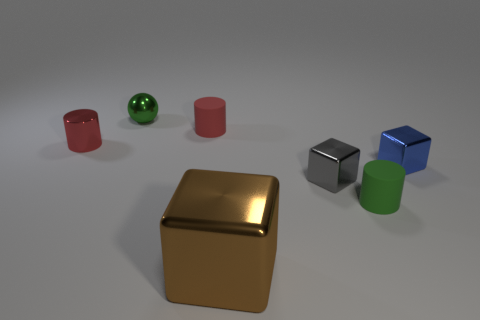How would you describe the lighting and shadows in this scene? The scene is evenly lit with a soft light source from above, casting gentle shadows directly underneath the objects. This illumination creates a calming ambiance and accentuates the shapes of the objects by producing muted shadows that give a sense of the dimensionality of the objects without being overly harsh. Does the lighting affect the colors of the objects in any way? Yes, the soft lighting minimally alters the colors of the objects, maintaining their vibrancy and allowing their true hues to be displayed. However, the reflective surfaces on some of the objects, such as the gold cube and green sphere, catch and reflect the light, which might slightly brighten their appearance and highlight their texture. 